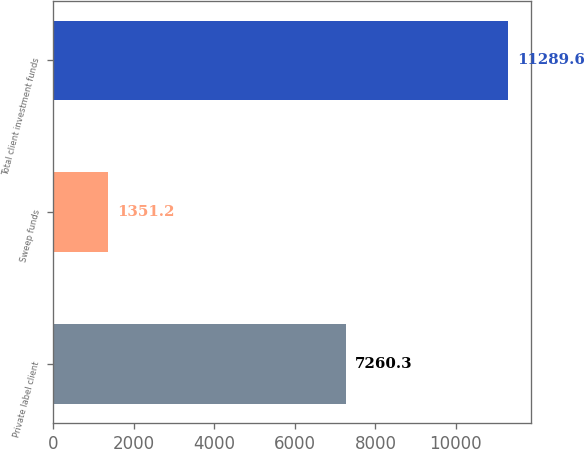Convert chart. <chart><loc_0><loc_0><loc_500><loc_500><bar_chart><fcel>Private label client<fcel>Sweep funds<fcel>Total client investment funds<nl><fcel>7260.3<fcel>1351.2<fcel>11289.6<nl></chart> 